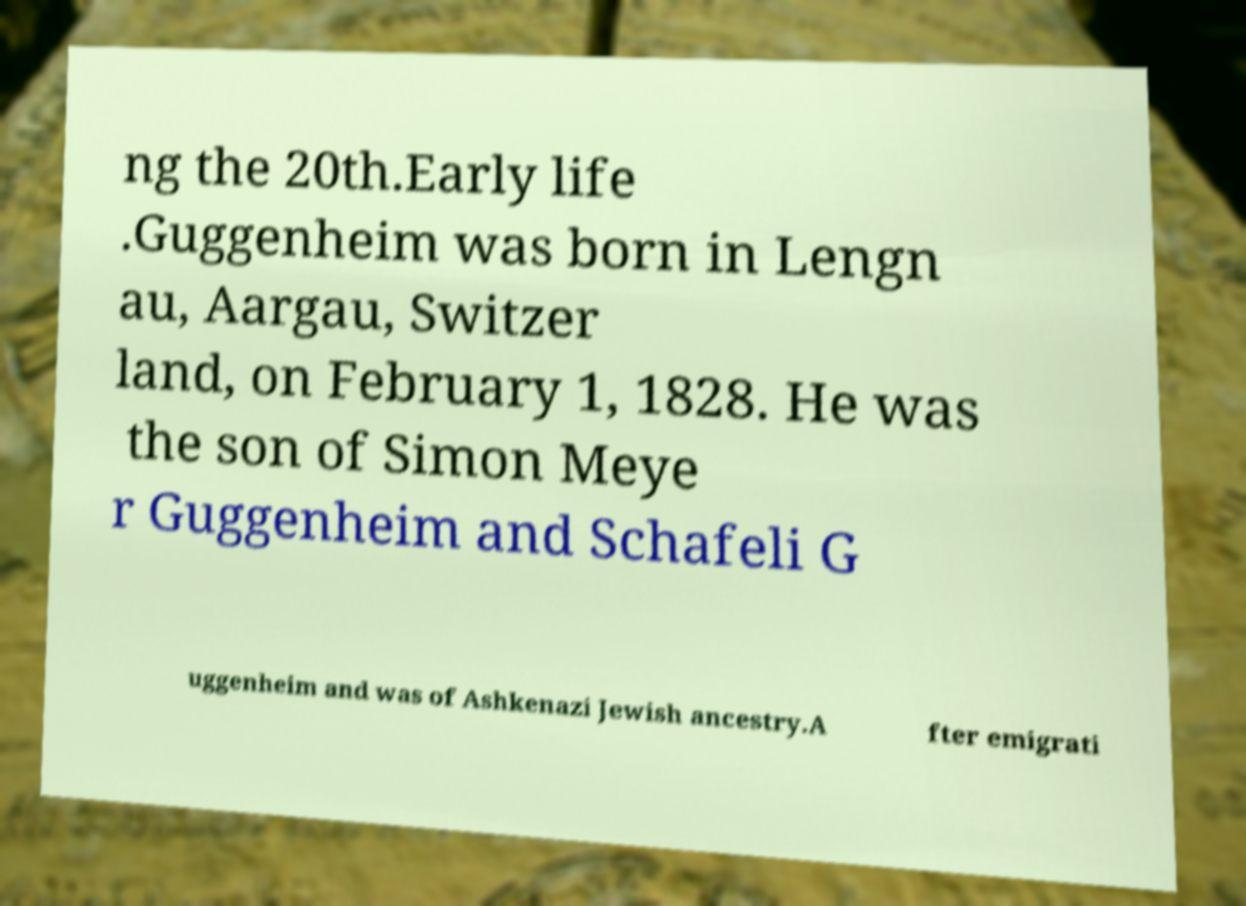There's text embedded in this image that I need extracted. Can you transcribe it verbatim? ng the 20th.Early life .Guggenheim was born in Lengn au, Aargau, Switzer land, on February 1, 1828. He was the son of Simon Meye r Guggenheim and Schafeli G uggenheim and was of Ashkenazi Jewish ancestry.A fter emigrati 